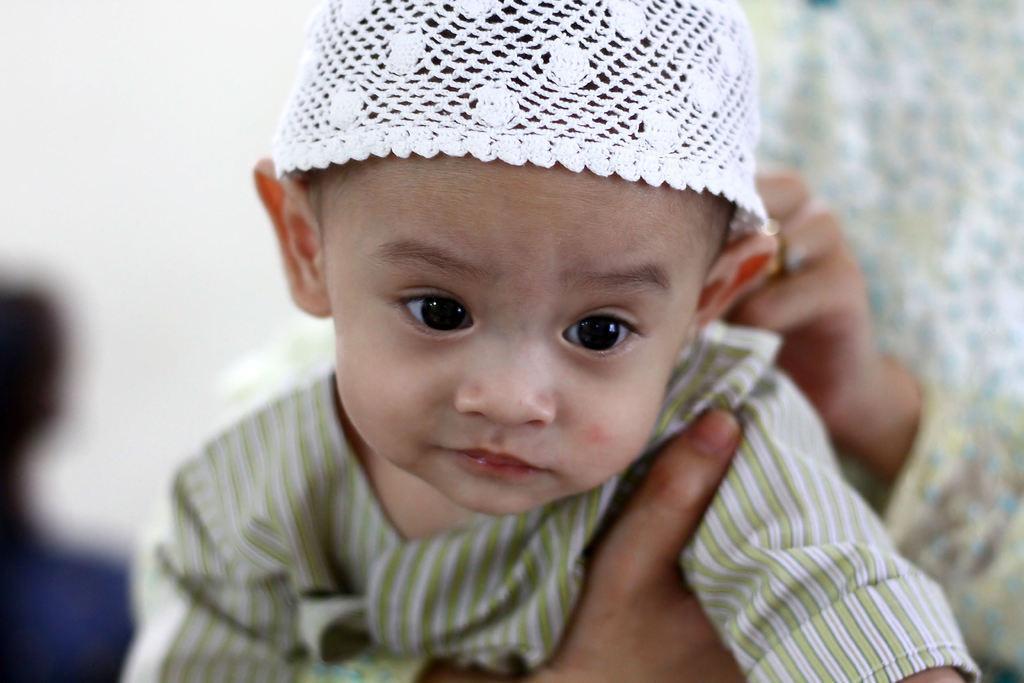Please provide a concise description of this image. In the picture we can see a child wearing a cap, which is white in color and any person holding the child from the back. 